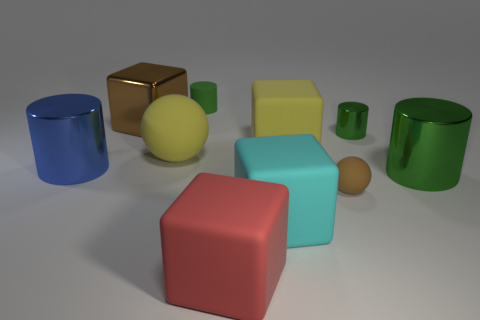Subtract all purple cubes. How many green cylinders are left? 3 Subtract 1 cubes. How many cubes are left? 3 Subtract all blue blocks. Subtract all cyan cylinders. How many blocks are left? 4 Subtract all cylinders. How many objects are left? 6 Subtract 0 red balls. How many objects are left? 10 Subtract all metallic cylinders. Subtract all metallic cylinders. How many objects are left? 4 Add 6 blue metallic objects. How many blue metallic objects are left? 7 Add 8 tiny cyan blocks. How many tiny cyan blocks exist? 8 